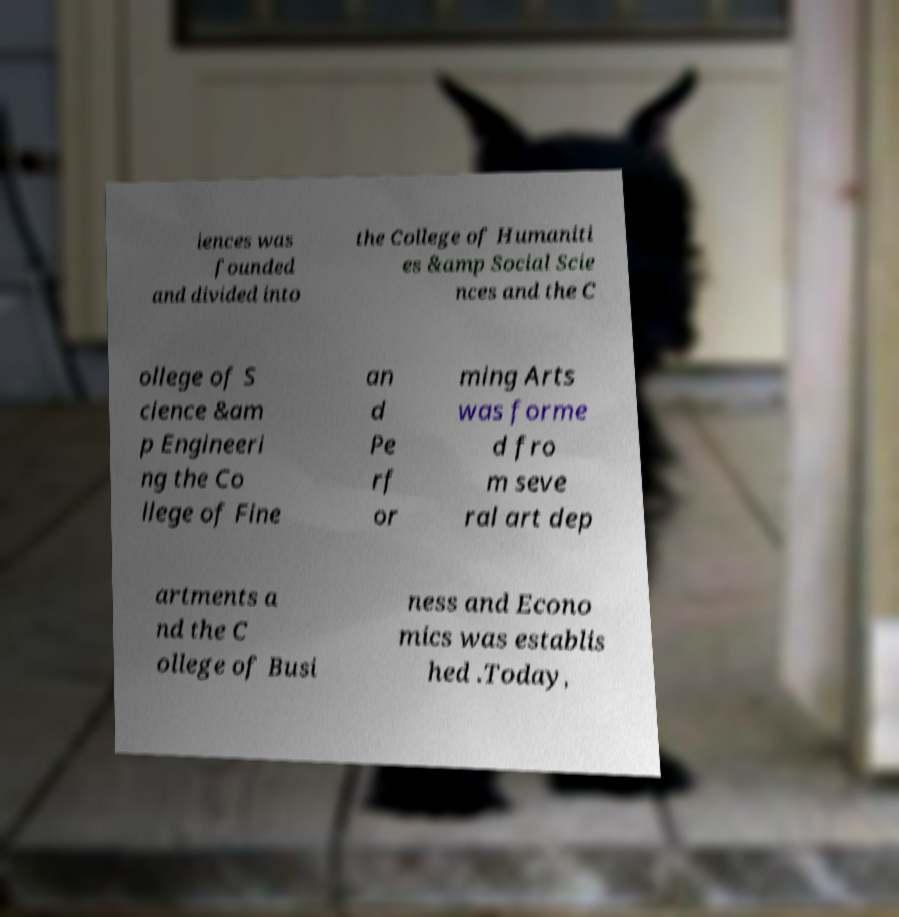Please identify and transcribe the text found in this image. iences was founded and divided into the College of Humaniti es &amp Social Scie nces and the C ollege of S cience &am p Engineeri ng the Co llege of Fine an d Pe rf or ming Arts was forme d fro m seve ral art dep artments a nd the C ollege of Busi ness and Econo mics was establis hed .Today, 